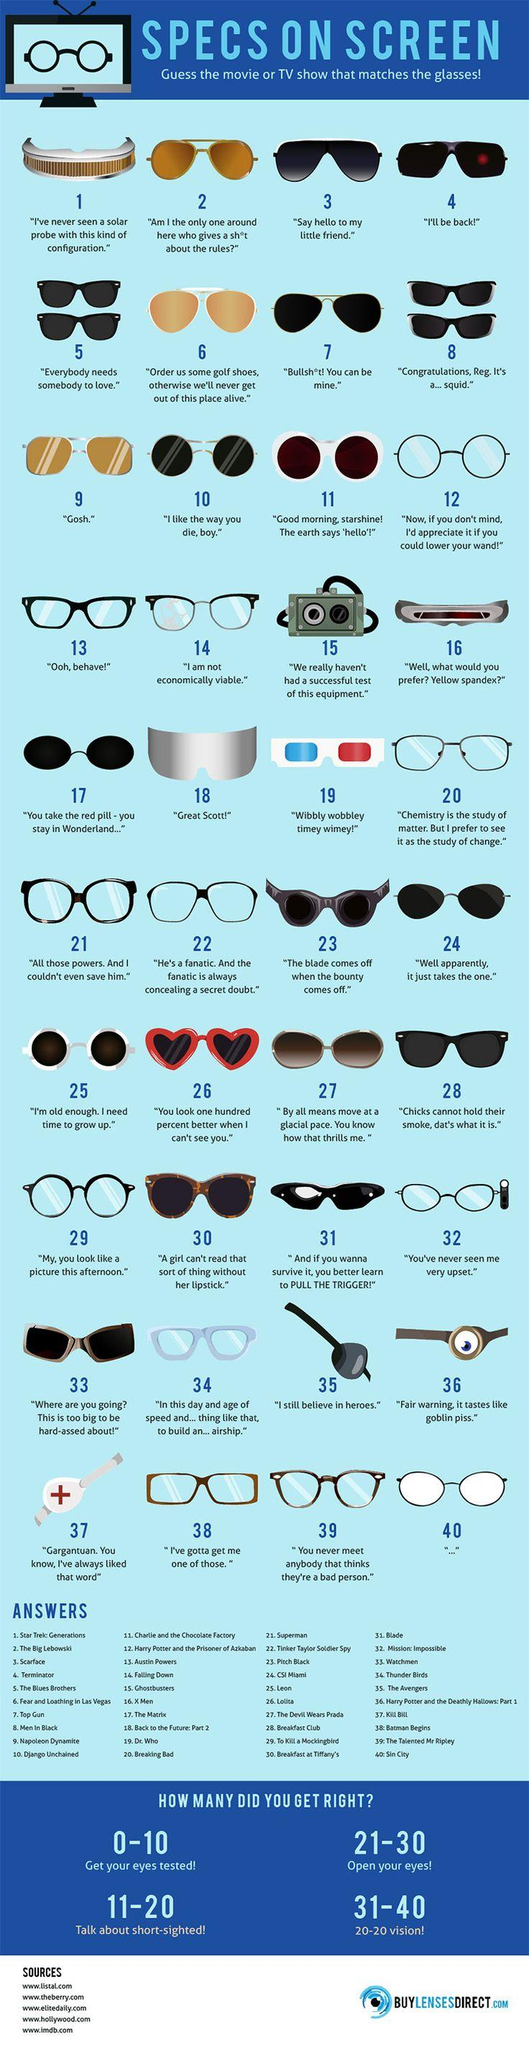Identify some key points in this picture. The glass that is suitable for the phrase 'I still believe in heroes' is The Avengers. Which glass is suitable for the occasion of saying 'Great Scott!' from the movie 'Back to the Future: Part 2'? The glass that is suitable for the phrase 'I'll be back!' from the film Terminator is... Napoleon Dynamite Which glass is suitable for 'Sin City'? 